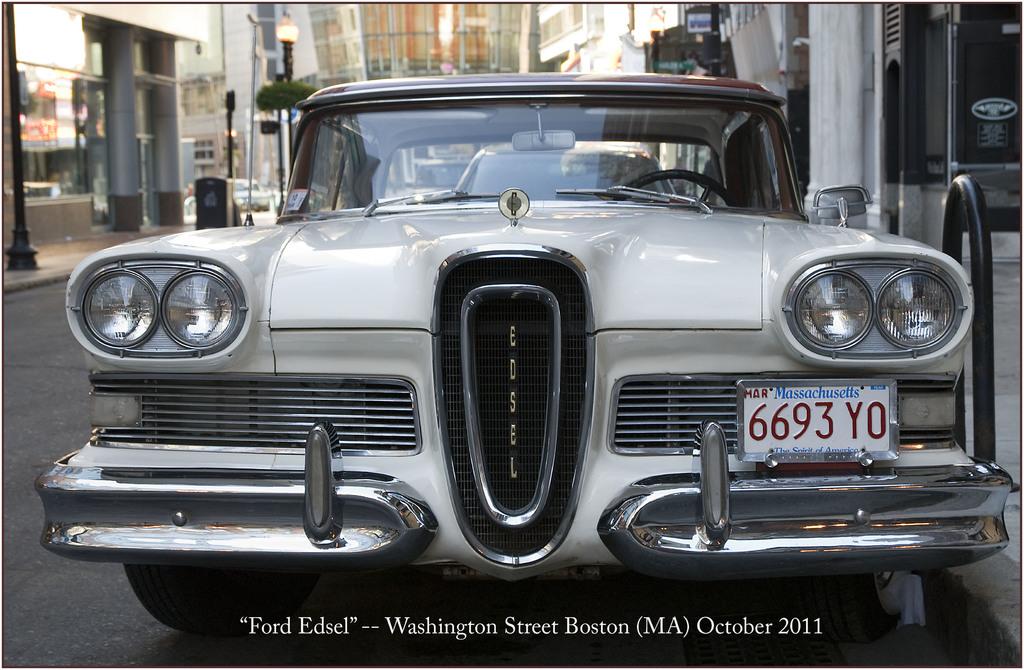What is the state on the plate?
Your response must be concise. Massachusetts. 